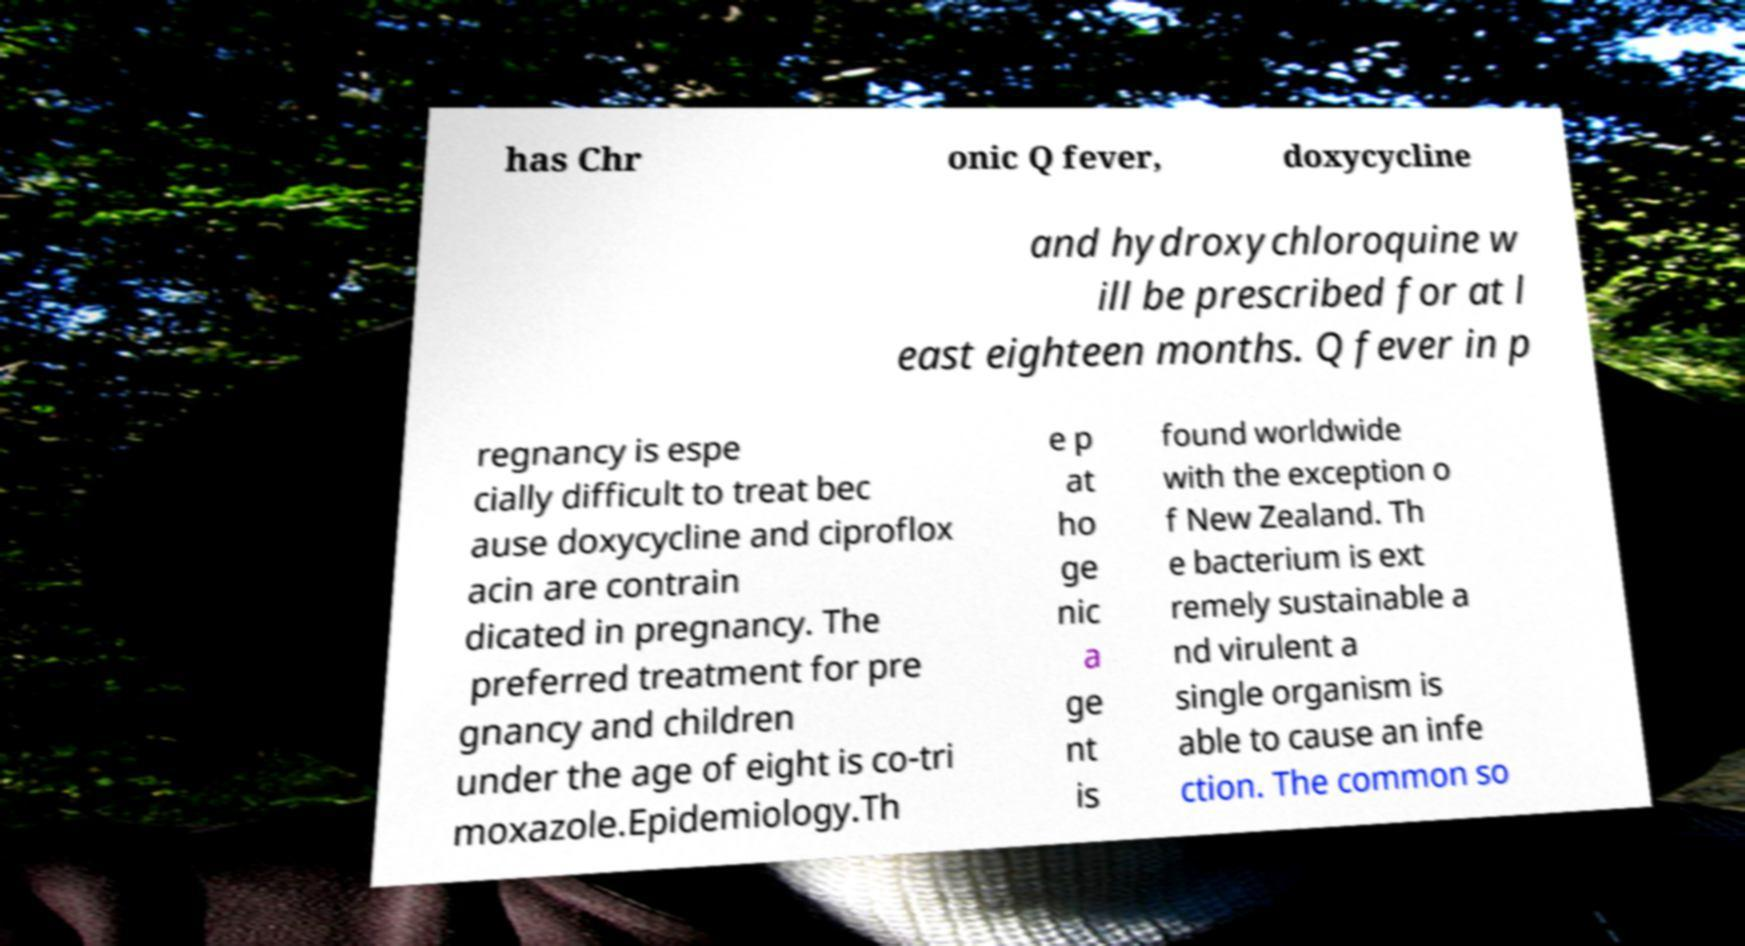There's text embedded in this image that I need extracted. Can you transcribe it verbatim? has Chr onic Q fever, doxycycline and hydroxychloroquine w ill be prescribed for at l east eighteen months. Q fever in p regnancy is espe cially difficult to treat bec ause doxycycline and ciproflox acin are contrain dicated in pregnancy. The preferred treatment for pre gnancy and children under the age of eight is co-tri moxazole.Epidemiology.Th e p at ho ge nic a ge nt is found worldwide with the exception o f New Zealand. Th e bacterium is ext remely sustainable a nd virulent a single organism is able to cause an infe ction. The common so 